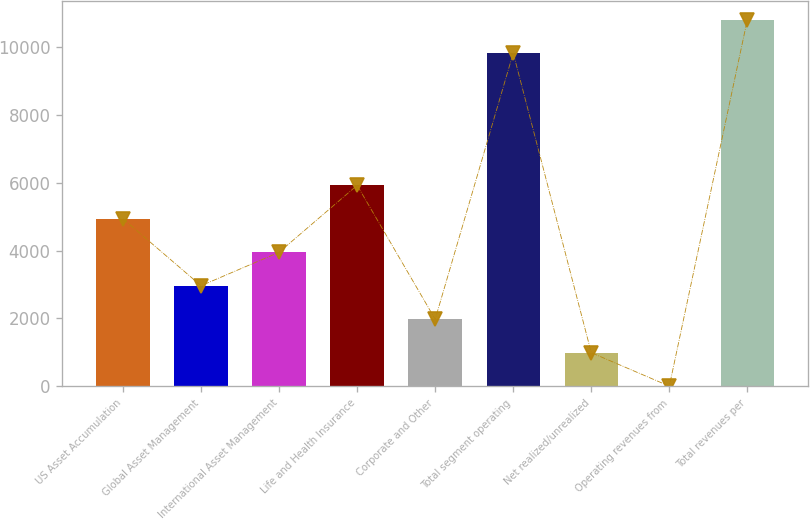<chart> <loc_0><loc_0><loc_500><loc_500><bar_chart><fcel>US Asset Accumulation<fcel>Global Asset Management<fcel>International Asset Management<fcel>Life and Health Insurance<fcel>Corporate and Other<fcel>Total segment operating<fcel>Net realized/unrealized<fcel>Operating revenues from<fcel>Total revenues per<nl><fcel>4938.1<fcel>2964.1<fcel>3951.1<fcel>5925.1<fcel>1977.1<fcel>9825.8<fcel>990.1<fcel>3.1<fcel>10812.8<nl></chart> 